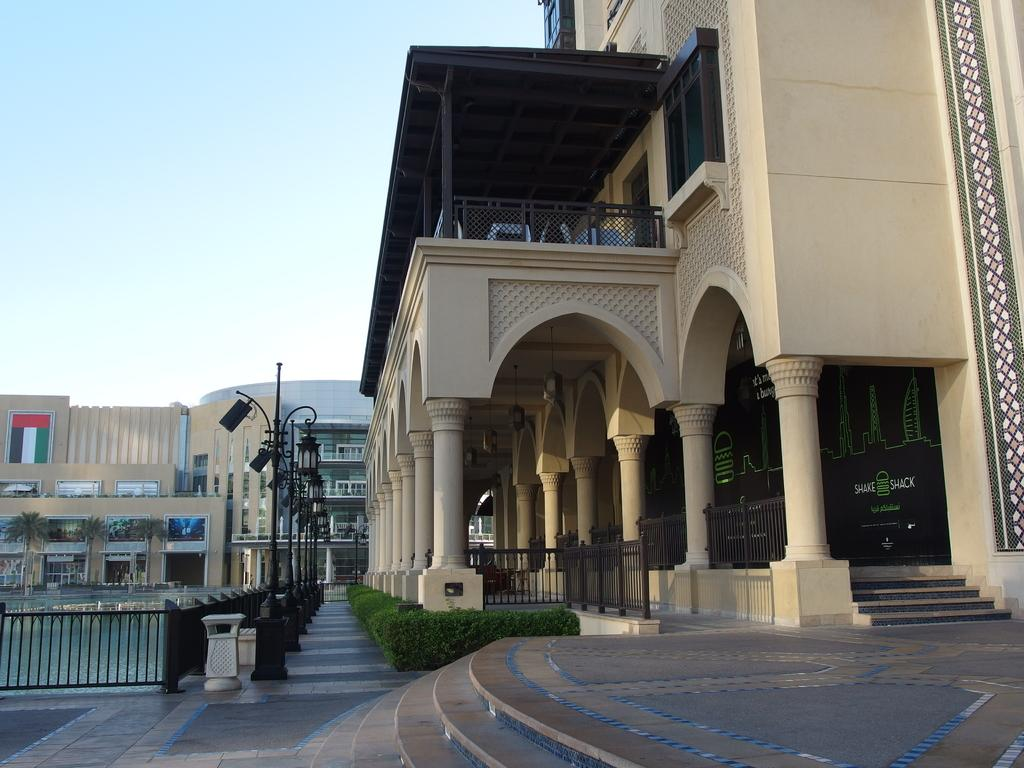What type of living organisms can be seen in the image? Plants and trees are visible in the image. What architectural features can be seen in the image? Railings, poles, and buildings are visible in the image. What part of the natural environment is visible in the image? Trees and the sky are visible in the image. Is there any text or writing present in the image? Yes, there is text or writing present in the image. What type of scent can be detected from the pail in the image? There is no pail present in the image, so it is not possible to detect any scent from it. How does the jelly interact with the plants in the image? There is no jelly present in the image, so it cannot interact with the plants. 